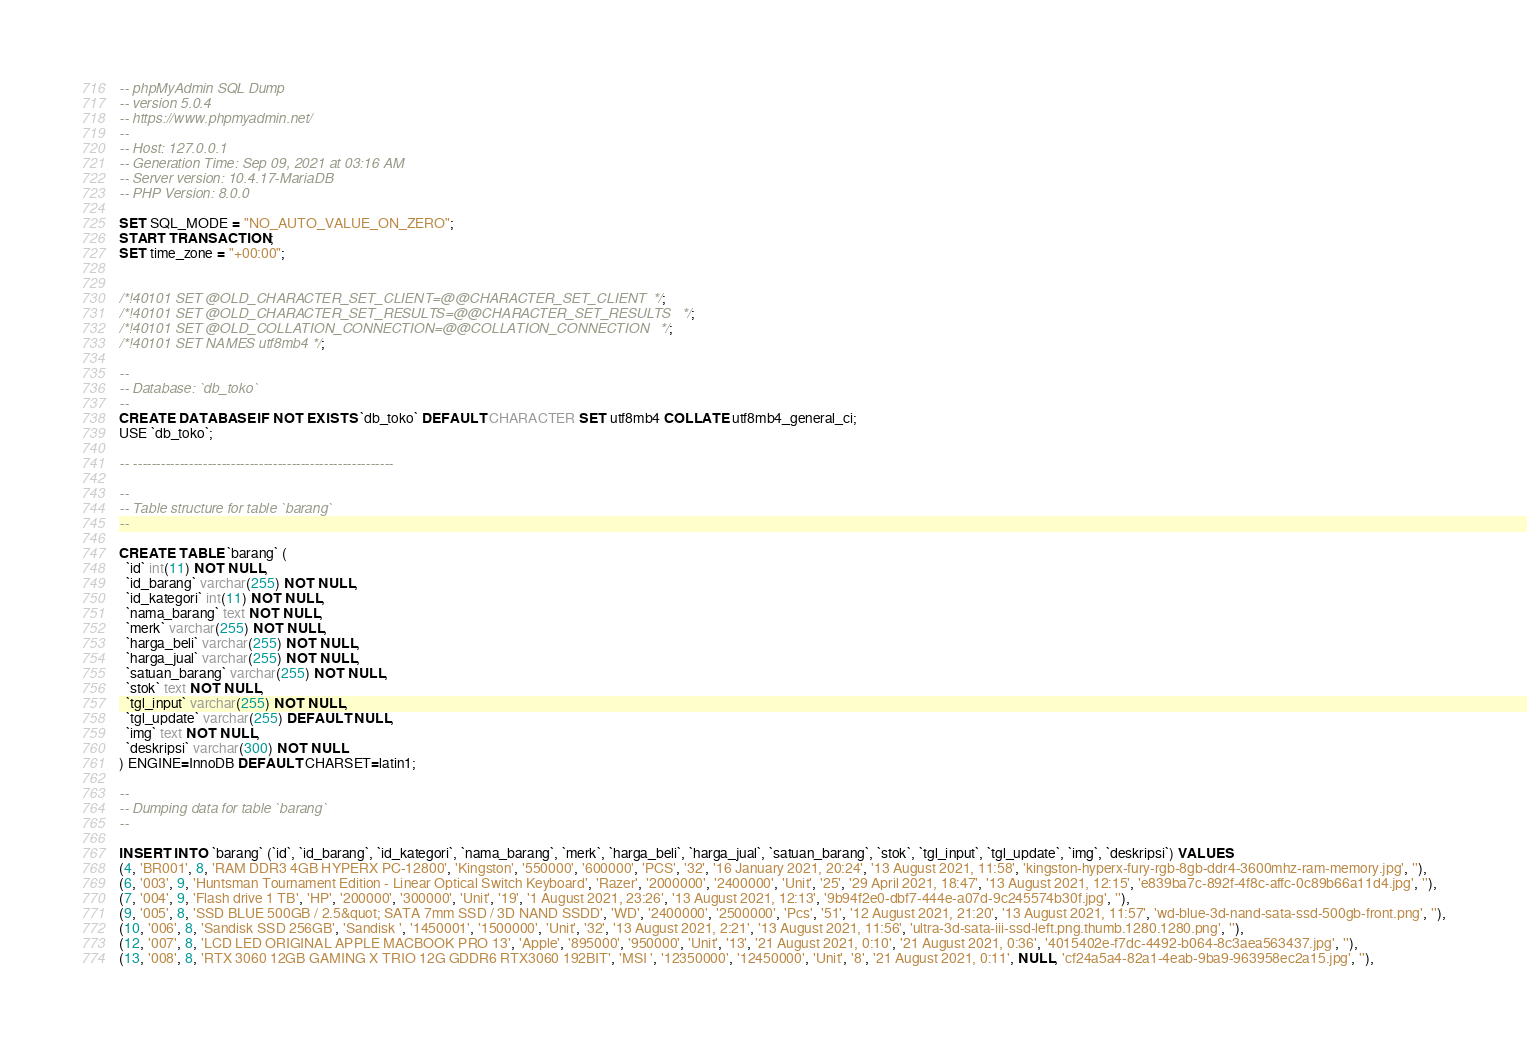<code> <loc_0><loc_0><loc_500><loc_500><_SQL_>-- phpMyAdmin SQL Dump
-- version 5.0.4
-- https://www.phpmyadmin.net/
--
-- Host: 127.0.0.1
-- Generation Time: Sep 09, 2021 at 03:16 AM
-- Server version: 10.4.17-MariaDB
-- PHP Version: 8.0.0

SET SQL_MODE = "NO_AUTO_VALUE_ON_ZERO";
START TRANSACTION;
SET time_zone = "+00:00";


/*!40101 SET @OLD_CHARACTER_SET_CLIENT=@@CHARACTER_SET_CLIENT */;
/*!40101 SET @OLD_CHARACTER_SET_RESULTS=@@CHARACTER_SET_RESULTS */;
/*!40101 SET @OLD_COLLATION_CONNECTION=@@COLLATION_CONNECTION */;
/*!40101 SET NAMES utf8mb4 */;

--
-- Database: `db_toko`
--
CREATE DATABASE IF NOT EXISTS `db_toko` DEFAULT CHARACTER SET utf8mb4 COLLATE utf8mb4_general_ci;
USE `db_toko`;

-- --------------------------------------------------------

--
-- Table structure for table `barang`
--

CREATE TABLE `barang` (
  `id` int(11) NOT NULL,
  `id_barang` varchar(255) NOT NULL,
  `id_kategori` int(11) NOT NULL,
  `nama_barang` text NOT NULL,
  `merk` varchar(255) NOT NULL,
  `harga_beli` varchar(255) NOT NULL,
  `harga_jual` varchar(255) NOT NULL,
  `satuan_barang` varchar(255) NOT NULL,
  `stok` text NOT NULL,
  `tgl_input` varchar(255) NOT NULL,
  `tgl_update` varchar(255) DEFAULT NULL,
  `img` text NOT NULL,
  `deskripsi` varchar(300) NOT NULL
) ENGINE=InnoDB DEFAULT CHARSET=latin1;

--
-- Dumping data for table `barang`
--

INSERT INTO `barang` (`id`, `id_barang`, `id_kategori`, `nama_barang`, `merk`, `harga_beli`, `harga_jual`, `satuan_barang`, `stok`, `tgl_input`, `tgl_update`, `img`, `deskripsi`) VALUES
(4, 'BR001', 8, 'RAM DDR3 4GB HYPERX PC-12800', 'Kingston', '550000', '600000', 'PCS', '32', '16 January 2021, 20:24', '13 August 2021, 11:58', 'kingston-hyperx-fury-rgb-8gb-ddr4-3600mhz-ram-memory.jpg', ''),
(6, '003', 9, 'Huntsman Tournament Edition - Linear Optical Switch Keyboard', 'Razer', '2000000', '2400000', 'Unit', '25', '29 April 2021, 18:47', '13 August 2021, 12:15', 'e839ba7c-892f-4f8c-affc-0c89b66a11d4.jpg', ''),
(7, '004', 9, 'Flash drive 1 TB', 'HP', '200000', '300000', 'Unit', '19', '1 August 2021, 23:26', '13 August 2021, 12:13', '9b94f2e0-dbf7-444e-a07d-9c245574b30f.jpg', ''),
(9, '005', 8, 'SSD BLUE 500GB / 2.5&quot; SATA 7mm SSD / 3D NAND SSDD', 'WD', '2400000', '2500000', 'Pcs', '51', '12 August 2021, 21:20', '13 August 2021, 11:57', 'wd-blue-3d-nand-sata-ssd-500gb-front.png', ''),
(10, '006', 8, 'Sandisk SSD 256GB', 'Sandisk ', '1450001', '1500000', 'Unit', '32', '13 August 2021, 2:21', '13 August 2021, 11:56', 'ultra-3d-sata-iii-ssd-left.png.thumb.1280.1280.png', ''),
(12, '007', 8, 'LCD LED ORIGINAL APPLE MACBOOK PRO 13', 'Apple', '895000', '950000', 'Unit', '13', '21 August 2021, 0:10', '21 August 2021, 0:36', '4015402e-f7dc-4492-b064-8c3aea563437.jpg', ''),
(13, '008', 8, 'RTX 3060 12GB GAMING X TRIO 12G GDDR6 RTX3060 192BIT', 'MSI ', '12350000', '12450000', 'Unit', '8', '21 August 2021, 0:11', NULL, 'cf24a5a4-82a1-4eab-9ba9-963958ec2a15.jpg', ''),</code> 